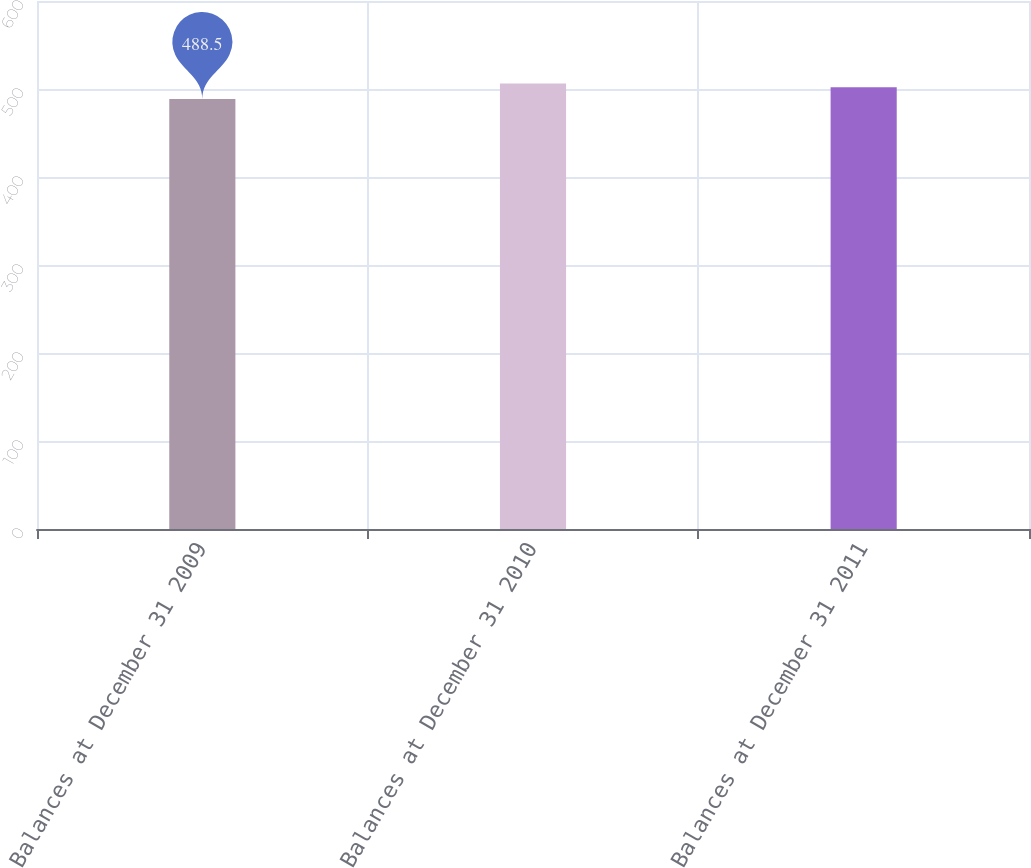Convert chart to OTSL. <chart><loc_0><loc_0><loc_500><loc_500><bar_chart><fcel>Balances at December 31 2009<fcel>Balances at December 31 2010<fcel>Balances at December 31 2011<nl><fcel>488.5<fcel>506.3<fcel>502<nl></chart> 